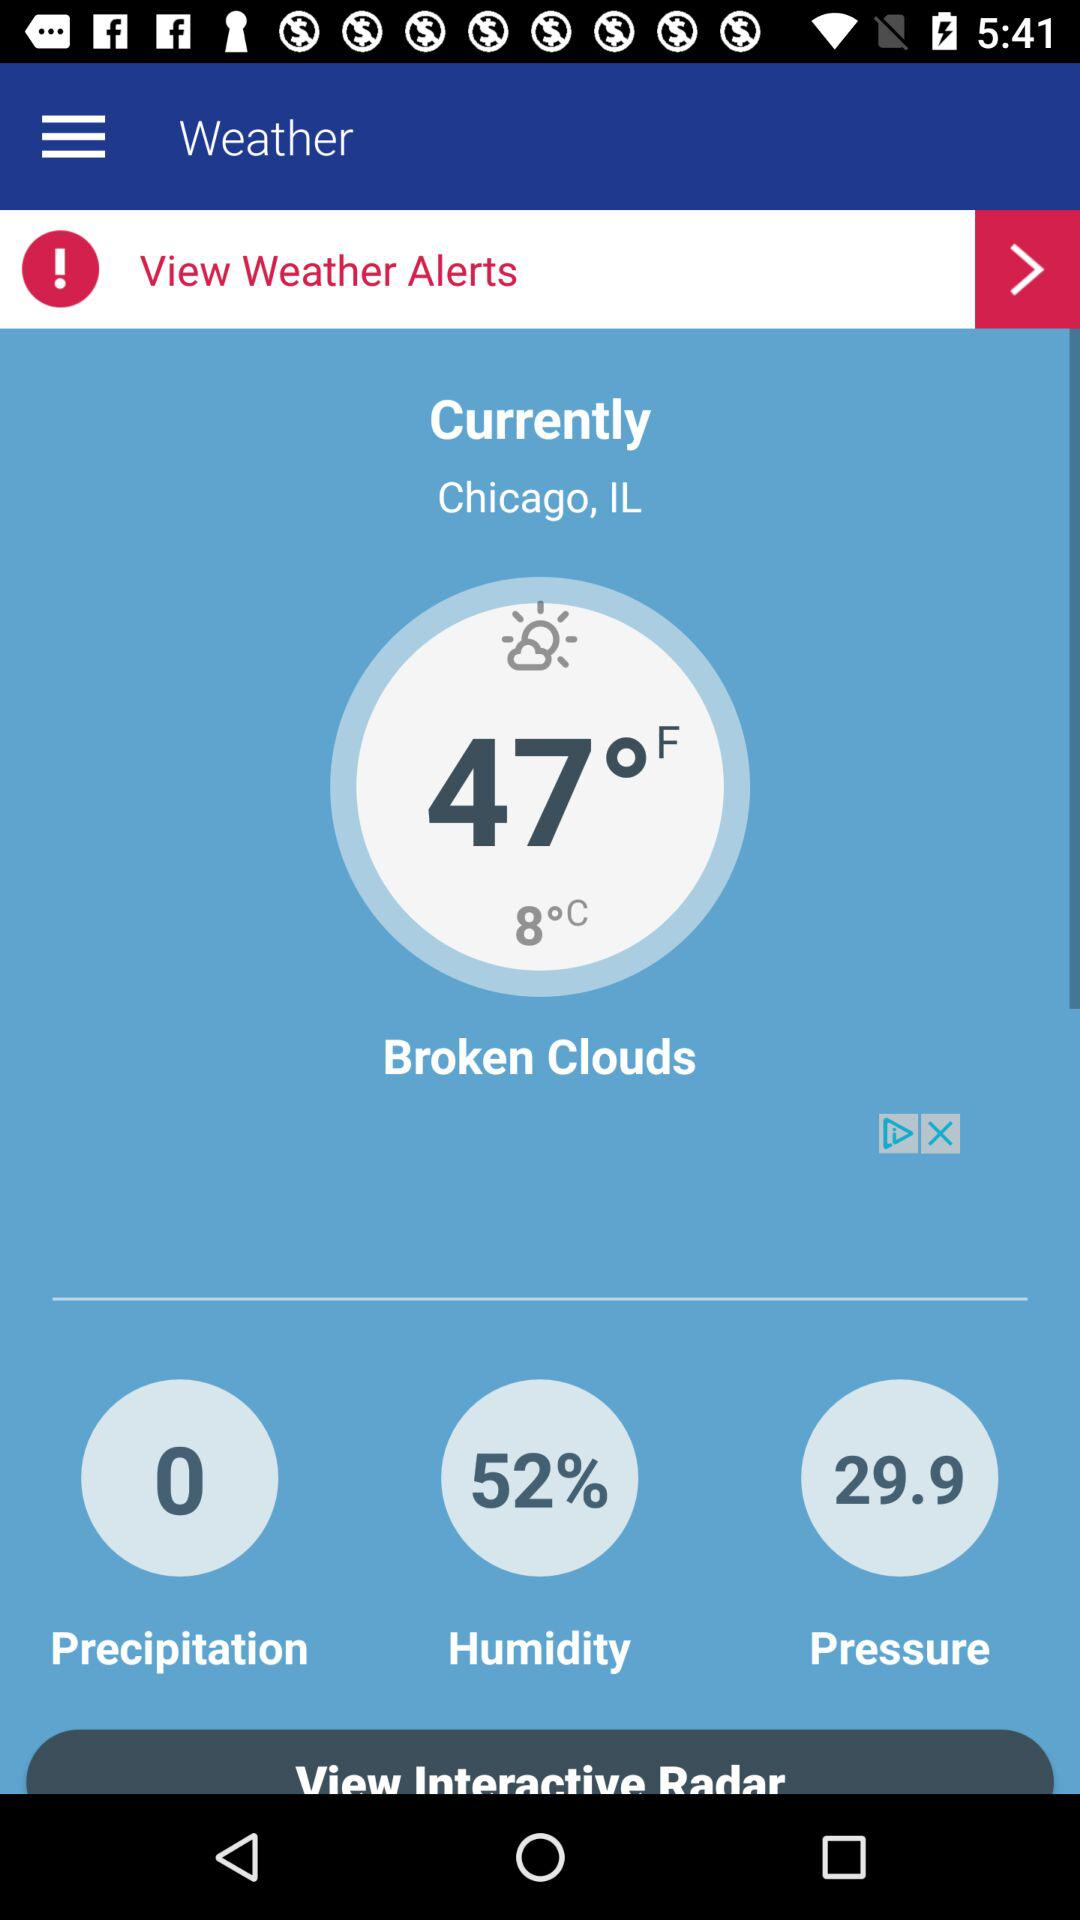What is the pressure? The pressure is 29.9. 